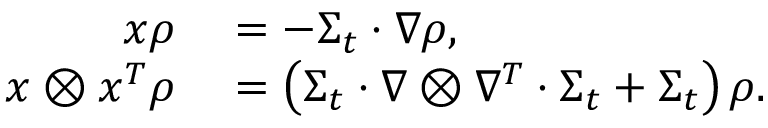<formula> <loc_0><loc_0><loc_500><loc_500>\begin{array} { r l } { x \rho } & = - \Sigma _ { t } \cdot \nabla \rho , } \\ { x \otimes x ^ { T } \rho } & = \left ( \Sigma _ { t } \cdot \nabla \otimes \nabla ^ { T } \cdot \Sigma _ { t } + \Sigma _ { t } \right ) \rho . } \end{array}</formula> 